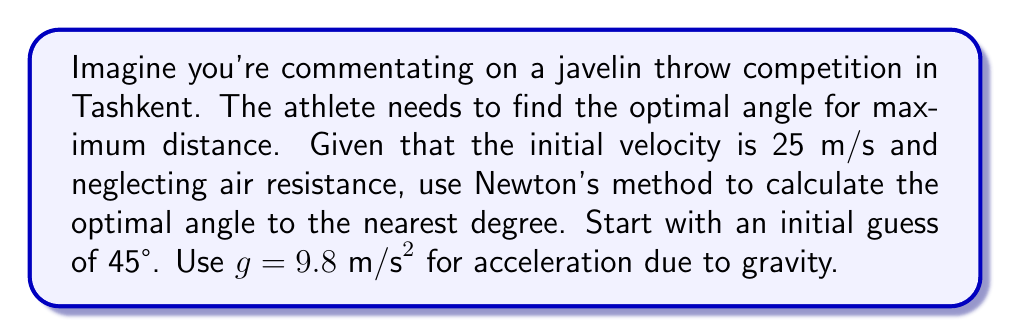Help me with this question. Let's approach this step-by-step:

1) The range equation for a projectile is:

   $$R = \frac{v^2}{g} \sin(2\theta)$$

   where $R$ is the range, $v$ is the initial velocity, $g$ is the acceleration due to gravity, and $\theta$ is the launch angle.

2) To find the maximum range, we need to find where the derivative of $R$ with respect to $\theta$ is zero:

   $$\frac{dR}{d\theta} = \frac{2v^2}{g} \cos(2\theta) = 0$$

3) This occurs when $\cos(2\theta) = 0$, or when $2\theta = 90°$. Therefore, the optimal angle is 45°. However, let's use Newton's method to find this.

4) Newton's method is given by:

   $$\theta_{n+1} = \theta_n - \frac{f(\theta_n)}{f'(\theta_n)}$$

   where $f(\theta) = \frac{2v^2}{g} \cos(2\theta)$ and $f'(\theta) = -\frac{4v^2}{g} \sin(2\theta)$

5) Let's start with $\theta_0 = 45° = \frac{\pi}{4}$ radians:

   $$\theta_1 = \frac{\pi}{4} - \frac{\frac{2(25)^2}{9.8} \cos(2\frac{\pi}{4})}{-\frac{4(25)^2}{9.8} \sin(2\frac{\pi}{4})} = \frac{\pi}{4} - 0 = \frac{\pi}{4}$$

6) We've already reached the optimal angle in one iteration! This is because our initial guess was correct.

7) Converting back to degrees: $\frac{\pi}{4} \approx 45°$
Answer: 45° 